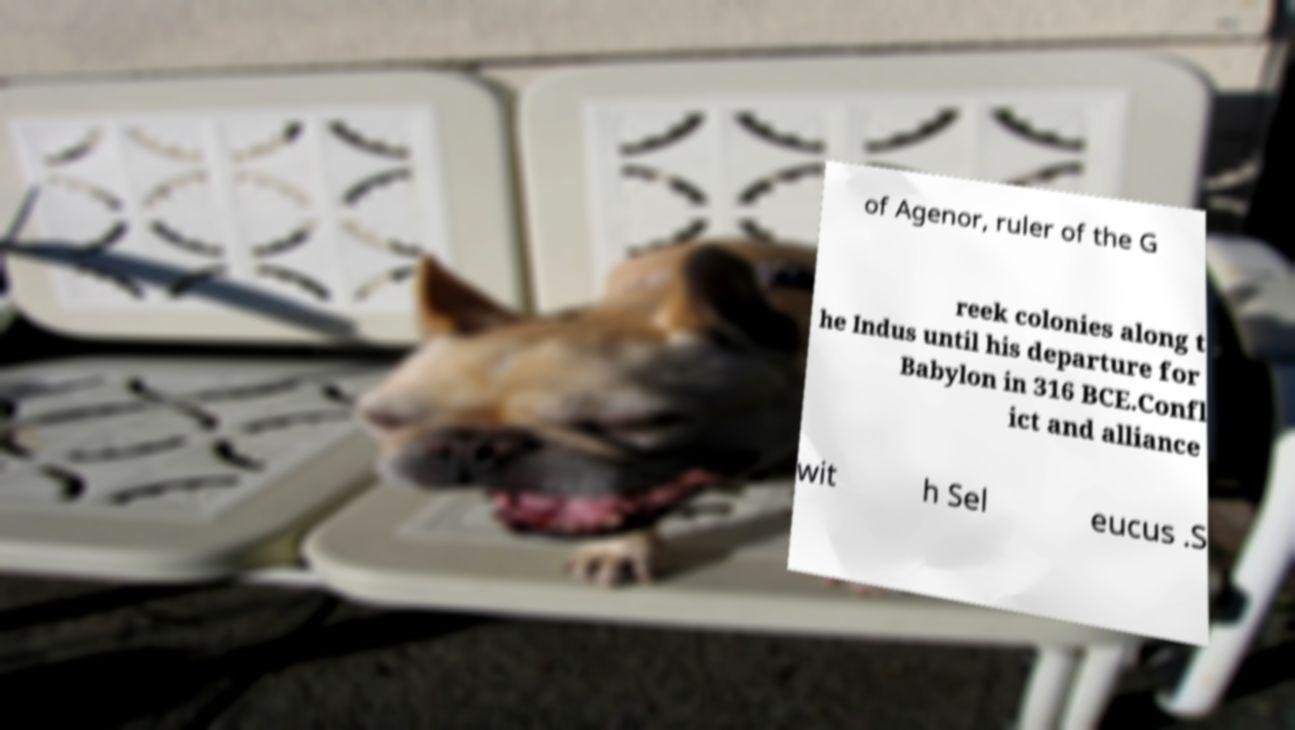Can you read and provide the text displayed in the image?This photo seems to have some interesting text. Can you extract and type it out for me? of Agenor, ruler of the G reek colonies along t he Indus until his departure for Babylon in 316 BCE.Confl ict and alliance wit h Sel eucus .S 